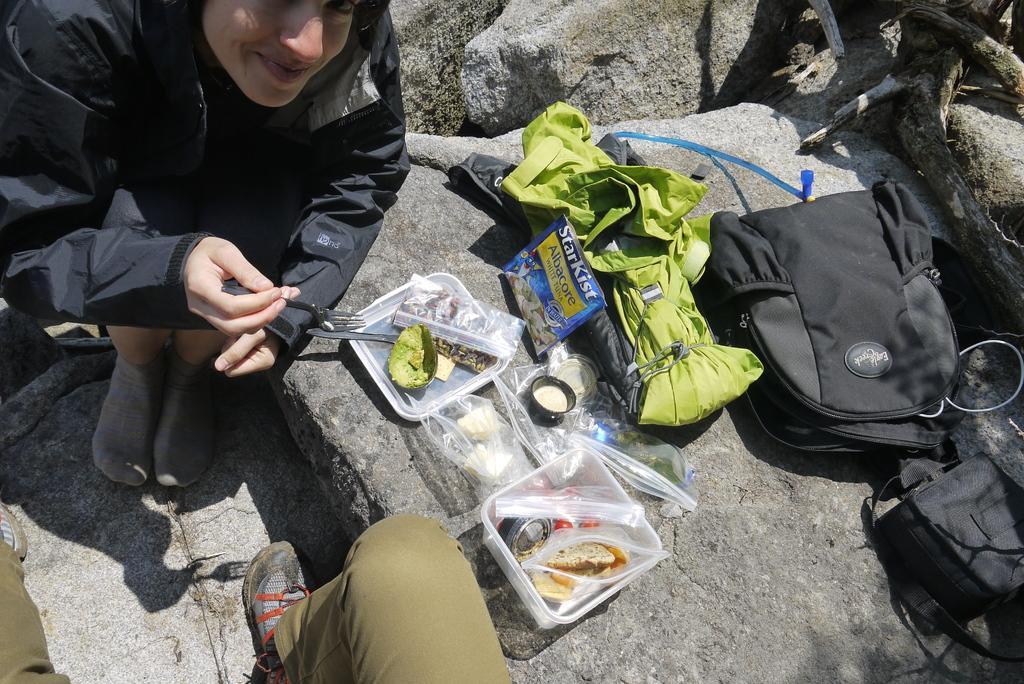Describe this image in one or two sentences. This is image consist of a person and there is a rock ,on the there are back packs and green color cloth and there are the boxes and food item on the box kept on the rock and a person leg is visible on the middle corner. 